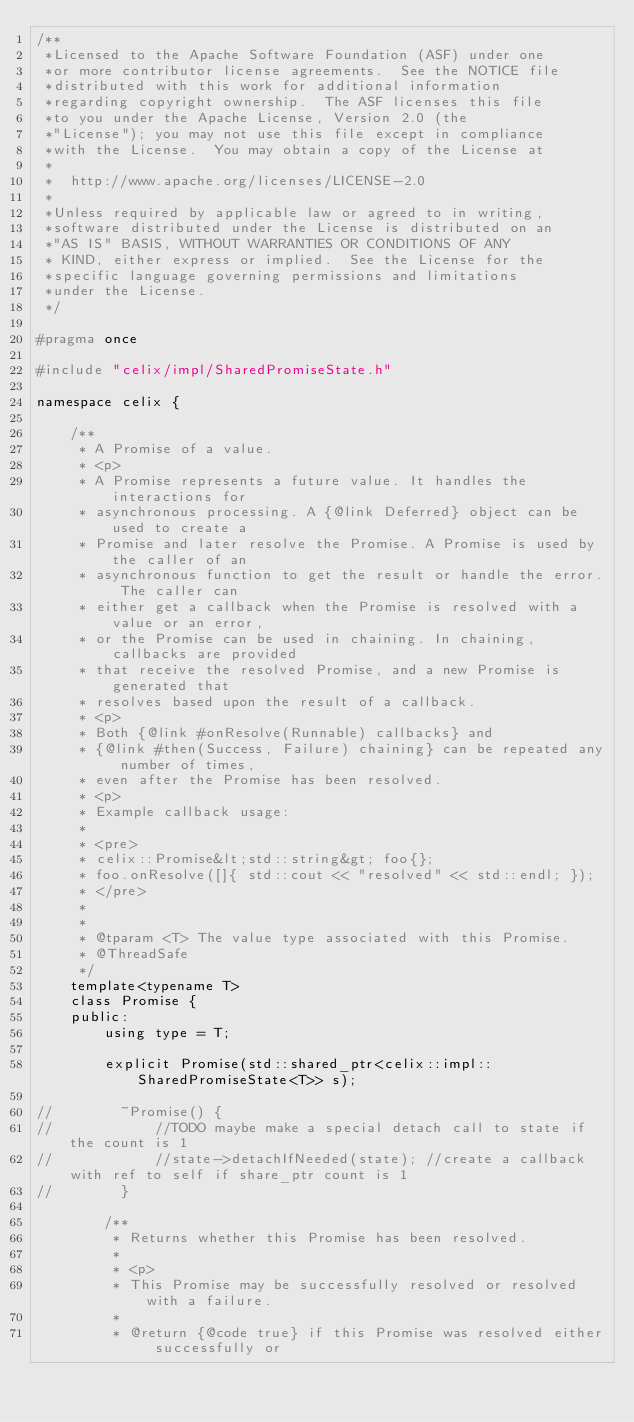<code> <loc_0><loc_0><loc_500><loc_500><_C_>/**
 *Licensed to the Apache Software Foundation (ASF) under one
 *or more contributor license agreements.  See the NOTICE file
 *distributed with this work for additional information
 *regarding copyright ownership.  The ASF licenses this file
 *to you under the Apache License, Version 2.0 (the
 *"License"); you may not use this file except in compliance
 *with the License.  You may obtain a copy of the License at
 *
 *  http://www.apache.org/licenses/LICENSE-2.0
 *
 *Unless required by applicable law or agreed to in writing,
 *software distributed under the License is distributed on an
 *"AS IS" BASIS, WITHOUT WARRANTIES OR CONDITIONS OF ANY
 * KIND, either express or implied.  See the License for the
 *specific language governing permissions and limitations
 *under the License.
 */

#pragma once

#include "celix/impl/SharedPromiseState.h"

namespace celix {

    /**
     * A Promise of a value.
     * <p>
     * A Promise represents a future value. It handles the interactions for
     * asynchronous processing. A {@link Deferred} object can be used to create a
     * Promise and later resolve the Promise. A Promise is used by the caller of an
     * asynchronous function to get the result or handle the error. The caller can
     * either get a callback when the Promise is resolved with a value or an error,
     * or the Promise can be used in chaining. In chaining, callbacks are provided
     * that receive the resolved Promise, and a new Promise is generated that
     * resolves based upon the result of a callback.
     * <p>
     * Both {@link #onResolve(Runnable) callbacks} and
     * {@link #then(Success, Failure) chaining} can be repeated any number of times,
     * even after the Promise has been resolved.
     * <p>
     * Example callback usage:
     *
     * <pre>
     * celix::Promise&lt;std::string&gt; foo{};
     * foo.onResolve([]{ std::cout << "resolved" << std::endl; });
     * </pre>
     *
     *
     * @tparam <T> The value type associated with this Promise.
     * @ThreadSafe
     */
    template<typename T>
    class Promise {
    public:
        using type = T;

        explicit Promise(std::shared_ptr<celix::impl::SharedPromiseState<T>> s);

//        ~Promise() {
//            //TODO maybe make a special detach call to state if the count is 1
//            //state->detachIfNeeded(state); //create a callback with ref to self if share_ptr count is 1
//        }

        /**
         * Returns whether this Promise has been resolved.
         *
         * <p>
         * This Promise may be successfully resolved or resolved with a failure.
         *
         * @return {@code true} if this Promise was resolved either successfully or</code> 